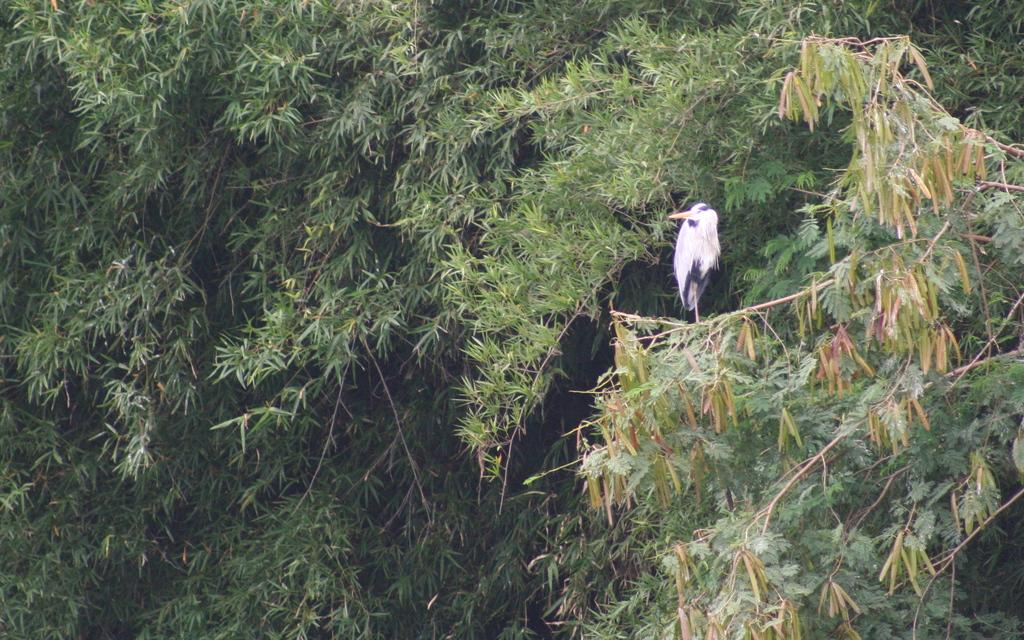What type of animal can be seen on the right side of the image? There is a bird on the right side of the image. What can be seen in the background of the image? There are trees visible in the background of the image. What type of fruit can be seen hanging from the branches of the trees in the image? There is no fruit visible in the image; only trees are present in the background. 